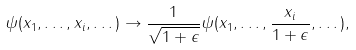<formula> <loc_0><loc_0><loc_500><loc_500>\psi ( x _ { 1 } , \dots , x _ { i } , \dots ) \rightarrow \frac { 1 } { \sqrt { 1 + \epsilon } } \psi ( x _ { 1 } , \dots , \frac { x _ { i } } { 1 + \epsilon } , \dots ) ,</formula> 